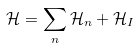<formula> <loc_0><loc_0><loc_500><loc_500>\mathcal { H } = \sum _ { n } \mathcal { H } _ { n } + \mathcal { H } _ { I }</formula> 